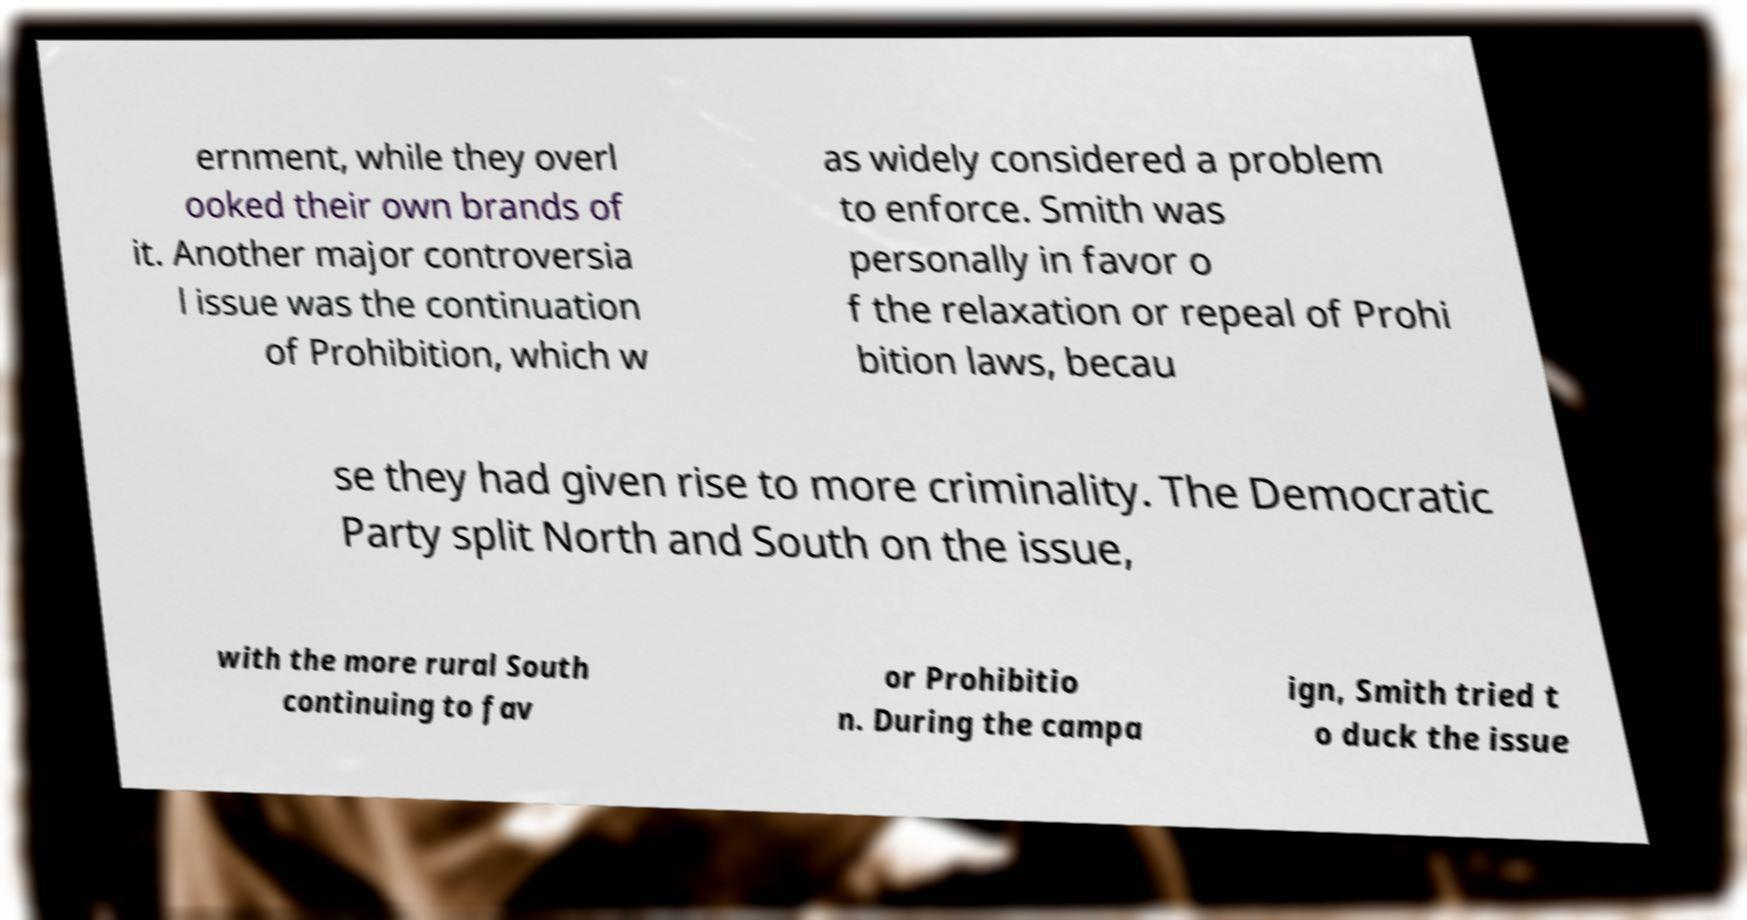Can you read and provide the text displayed in the image?This photo seems to have some interesting text. Can you extract and type it out for me? ernment, while they overl ooked their own brands of it. Another major controversia l issue was the continuation of Prohibition, which w as widely considered a problem to enforce. Smith was personally in favor o f the relaxation or repeal of Prohi bition laws, becau se they had given rise to more criminality. The Democratic Party split North and South on the issue, with the more rural South continuing to fav or Prohibitio n. During the campa ign, Smith tried t o duck the issue 